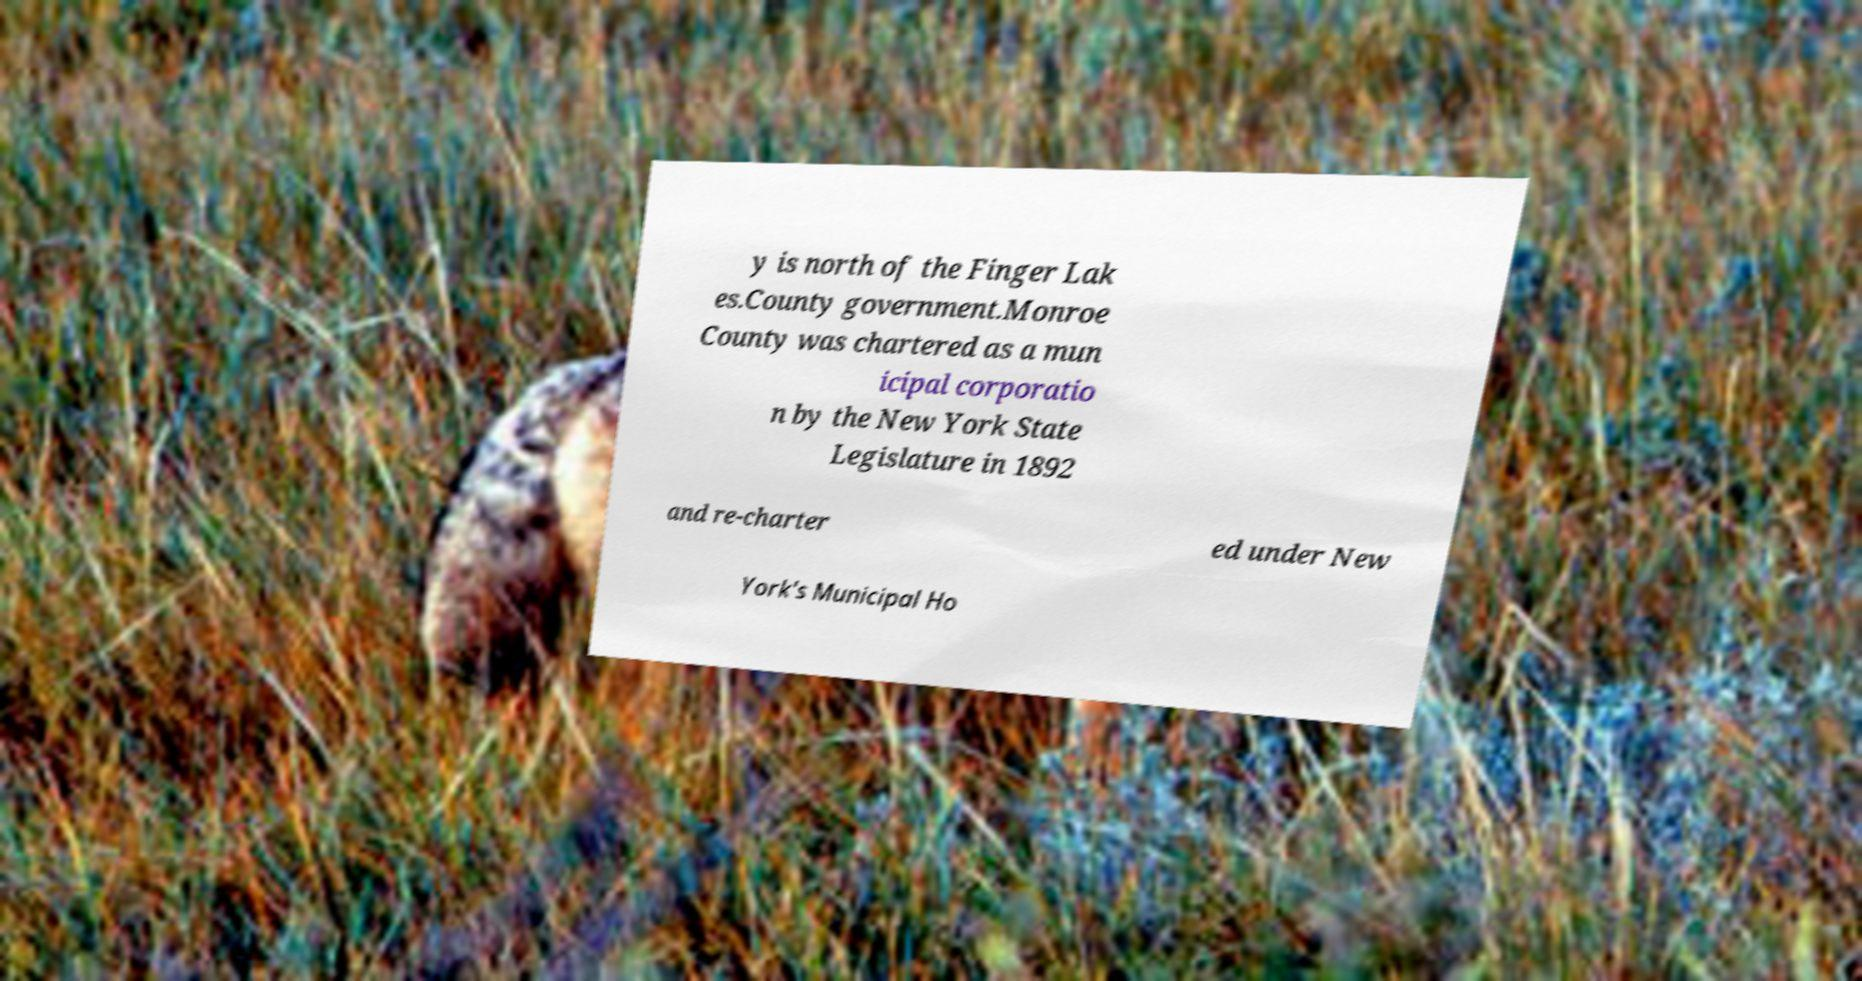What messages or text are displayed in this image? I need them in a readable, typed format. y is north of the Finger Lak es.County government.Monroe County was chartered as a mun icipal corporatio n by the New York State Legislature in 1892 and re-charter ed under New York's Municipal Ho 